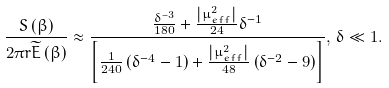Convert formula to latex. <formula><loc_0><loc_0><loc_500><loc_500>\frac { S \left ( \beta \right ) } { 2 \pi r \widetilde { E } \left ( \beta \right ) } \approx \frac { \frac { \delta ^ { - 3 } } { 1 8 0 } + \frac { \left | \mu _ { e f f } ^ { 2 } \right | } { 2 4 } \delta ^ { - 1 } } { \left [ \frac { 1 } { 2 4 0 } \left ( \delta ^ { - 4 } - 1 \right ) + \frac { \left | \mu _ { e f f } ^ { 2 } \right | } { 4 8 } \left ( \delta ^ { - 2 } - 9 \right ) \right ] } , \, \delta \ll 1 .</formula> 